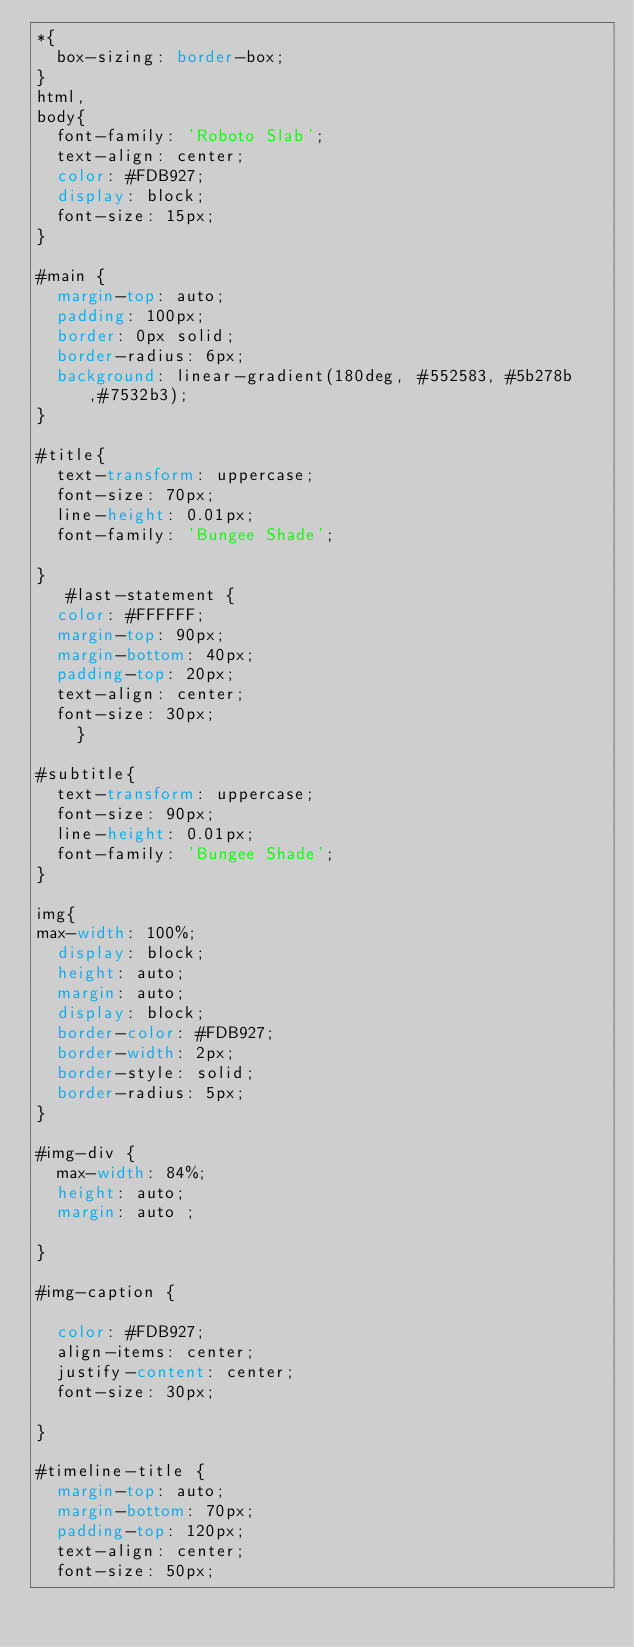<code> <loc_0><loc_0><loc_500><loc_500><_CSS_>*{
  box-sizing: border-box;
}
html,
body{
  font-family: 'Roboto Slab';
  text-align: center;
  color: #FDB927;
  display: block;
  font-size: 15px;
}
  
#main {
  margin-top: auto;
  padding: 100px;
  border: 0px solid;
  border-radius: 6px;
  background: linear-gradient(180deg, #552583, #5b278b,#7532b3);
}

#title{
  text-transform: uppercase;
  font-size: 70px;
  line-height: 0.01px;
  font-family: 'Bungee Shade';
  
}
   #last-statement {
  color: #FFFFFF;
  margin-top: 90px;
  margin-bottom: 40px;
  padding-top: 20px;
  text-align: center;
  font-size: 30px;
    }

#subtitle{
  text-transform: uppercase;
  font-size: 90px;
  line-height: 0.01px;
  font-family: 'Bungee Shade';
}

img{
max-width: 100%;
  display: block;
  height: auto;
  margin: auto;
  display: block;
  border-color: #FDB927;
  border-width: 2px;
  border-style: solid;
  border-radius: 5px;
}

#img-div {
  max-width: 84%;
  height: auto;
  margin: auto ;
 
}

#img-caption {
 
  color: #FDB927;
  align-items: center;
  justify-content: center;
  font-size: 30px;
 
}

#timeline-title {
  margin-top: auto;
  margin-bottom: 70px;
  padding-top: 120px;
  text-align: center;
  font-size: 50px;</code> 